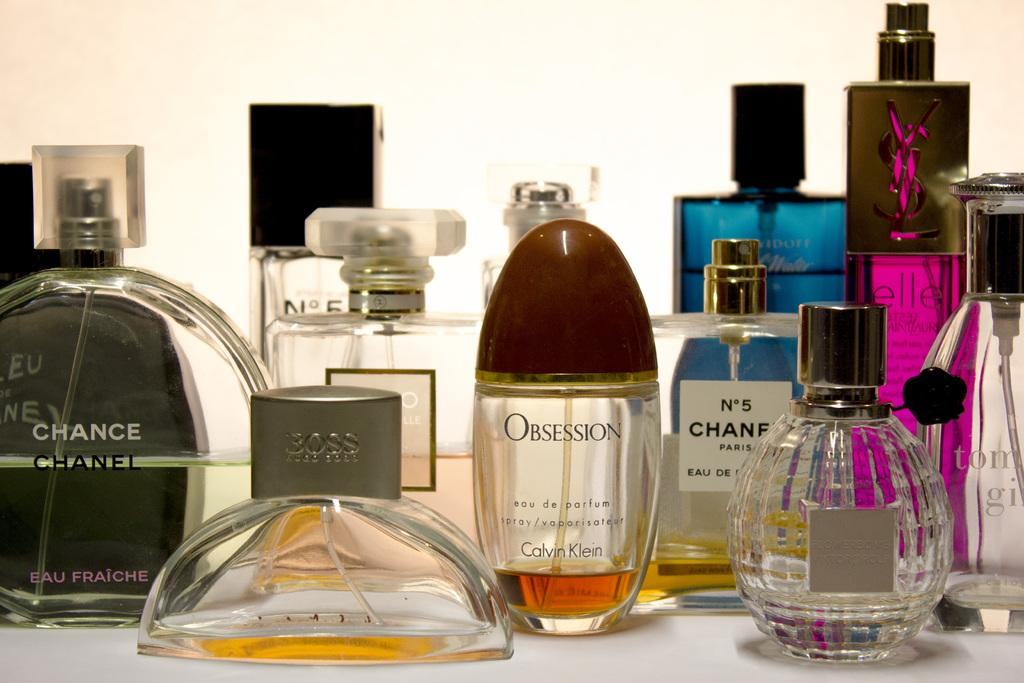<image>
Describe the image concisely. Twelve perfume bottles from brands such as Calvin Klein, Hugo Boss, Chanel, etc., are displayed, all at different levels of consumption. 